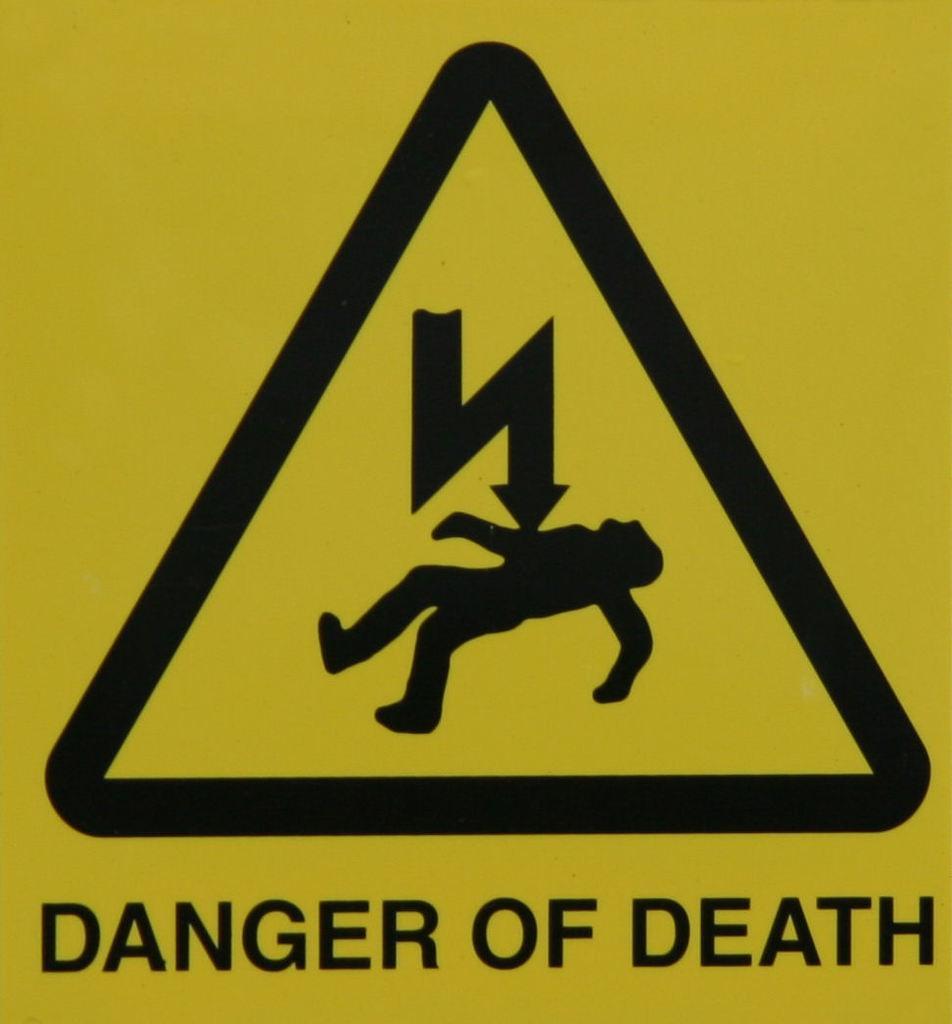Describe this image in one or two sentences. In this picture we can see a logo and text are present on the board. 